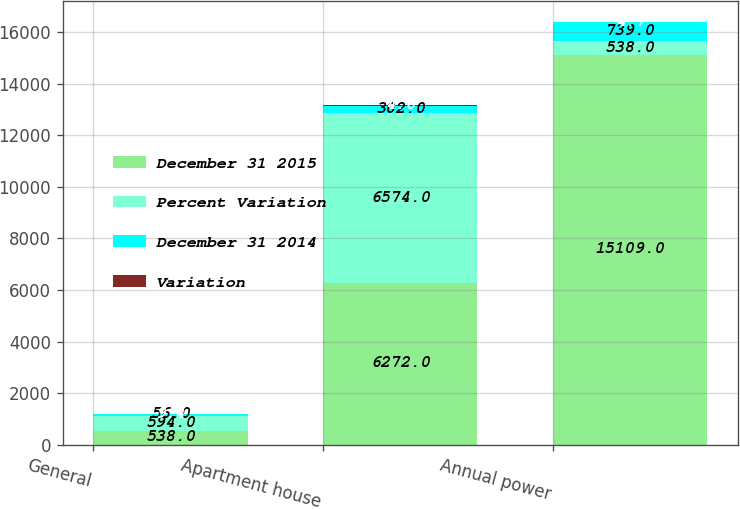Convert chart. <chart><loc_0><loc_0><loc_500><loc_500><stacked_bar_chart><ecel><fcel>General<fcel>Apartment house<fcel>Annual power<nl><fcel>December 31 2015<fcel>538<fcel>6272<fcel>15109<nl><fcel>Percent Variation<fcel>594<fcel>6574<fcel>538<nl><fcel>December 31 2014<fcel>56<fcel>302<fcel>739<nl><fcel>Variation<fcel>9.4<fcel>4.6<fcel>4.7<nl></chart> 